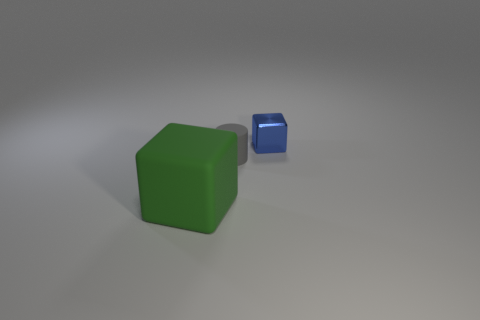What is the cube in front of the tiny metallic block made of?
Your answer should be compact. Rubber. Is there a blue metal cube that has the same size as the green block?
Your response must be concise. No. Is the color of the matte object in front of the gray thing the same as the matte cylinder?
Your answer should be compact. No. How many gray objects are either large cubes or metal blocks?
Make the answer very short. 0. Is the material of the cylinder the same as the blue cube?
Keep it short and to the point. No. There is a block that is behind the big object; how many large green matte objects are behind it?
Give a very brief answer. 0. Do the shiny cube and the gray matte cylinder have the same size?
Your response must be concise. Yes. What number of other objects are the same material as the green object?
Provide a short and direct response. 1. The green matte thing that is the same shape as the small metal thing is what size?
Offer a very short reply. Large. Is the shape of the matte object behind the large green block the same as  the blue thing?
Provide a short and direct response. No. 